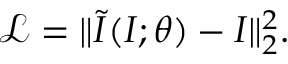Convert formula to latex. <formula><loc_0><loc_0><loc_500><loc_500>\mathcal { L } = \| \widetilde { I } ( I ; \theta ) - I \| _ { 2 } ^ { 2 } .</formula> 